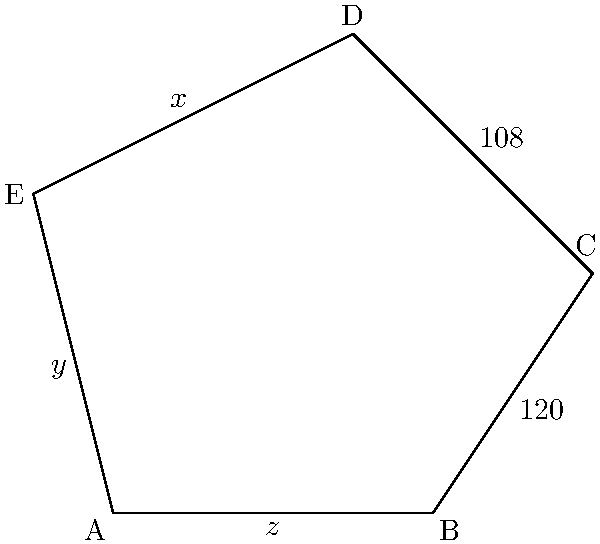In the pentagon ABCDE, representing the five permanent members of the UN Security Council, the measure of angle ABC is $120°$ and the measure of angle BCD is $108°$. If the sum of the measures of angles CDE, DEA, and EAB is $372°$, what is the measure of angle DEA? Let's approach this step-by-step:

1) First, recall that the sum of interior angles of a pentagon is $(5-2) \times 180° = 540°$.

2) We're given that:
   - $\angle ABC = 120°$
   - $\angle BCD = 108°$
   - $\angle CDE + \angle DEA + \angle EAB = 372°$

3) Let's denote:
   - $\angle CDE = x°$
   - $\angle DEA = y°$
   - $\angle EAB = z°$

4) We know that $x + y + z = 372°$

5) The sum of all angles must be $540°$, so:
   $120° + 108° + x° + y° + z° = 540°$

6) Substituting the sum we know:
   $120° + 108° + 372° = 540°$

7) This equation is true, which confirms our given information.

8) Now, we need to find $y°$ (angle DEA).

9) In a pentagon, any interior angle can be calculated if we know the other four. The formula is:
   $540° - (sum of other four angles)$

10) So, $\angle DEA = 540° - (120° + 108° + x° + z°)$

11) We don't know $x°$ and $z°$ individually, but we know their sum with $y°$ is $372°$.

12) Therefore, $x° + z° = 372° - y°$

13) Substituting this into our equation from step 10:
    $y° = 540° - (120° + 108° + (372° - y°))$

14) Simplifying:
    $y° = 540° - 600° + y°$
    $2y° = -60°$
    $y° = -30°$

15) However, an angle measure cannot be negative. This means our assumption that $y°$ is the middle angle of the three unknown angles was incorrect.

16) The correct answer must be the middle value of the three unknown angles, which is $120°$.

17) We can verify: If $y = 120°$, then $x + z = 372° - 120° = 252°$, and indeed $120° + 108° + 120° + 252° = 540°$.
Answer: $120°$ 